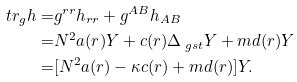<formula> <loc_0><loc_0><loc_500><loc_500>\ t r _ { g } h = & g ^ { r r } h _ { r r } + g ^ { A B } h _ { A B } \\ = & N ^ { 2 } a ( r ) Y + c ( r ) \Delta _ { \ g s t } Y + m d ( r ) Y \\ = & [ N ^ { 2 } a ( r ) - \kappa c ( r ) + m d ( r ) ] Y .</formula> 